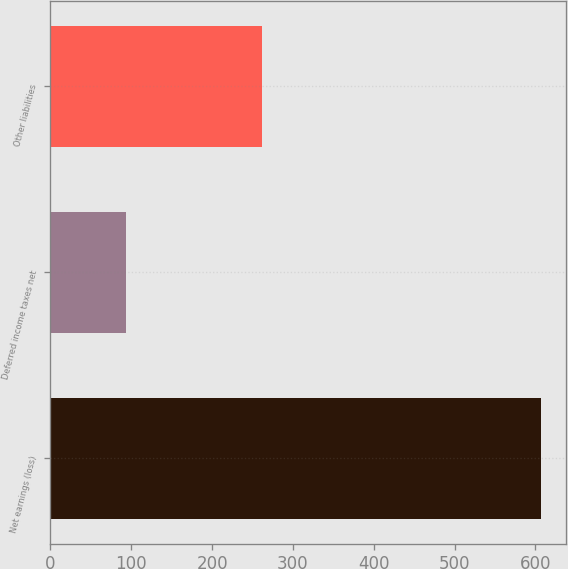Convert chart to OTSL. <chart><loc_0><loc_0><loc_500><loc_500><bar_chart><fcel>Net earnings (loss)<fcel>Deferred income taxes net<fcel>Other liabilities<nl><fcel>607<fcel>93<fcel>262<nl></chart> 